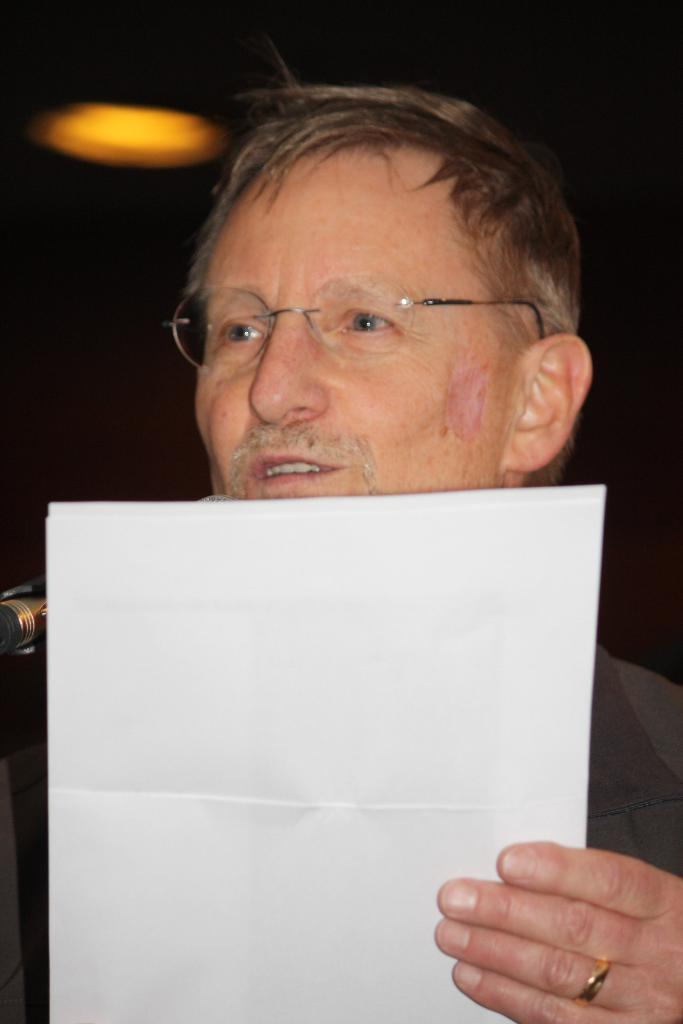What is the person in the image doing? The person in the image is holding papers. What color light is visible in the image? There is a yellow light visible in the image. What is the color of the background in the image? The background of the image is black. What type of aunt can be seen in the image? There is no aunt present in the image. What is the person in the image doing with their partner? There is no partner present in the image, and the person is simply holding papers. 